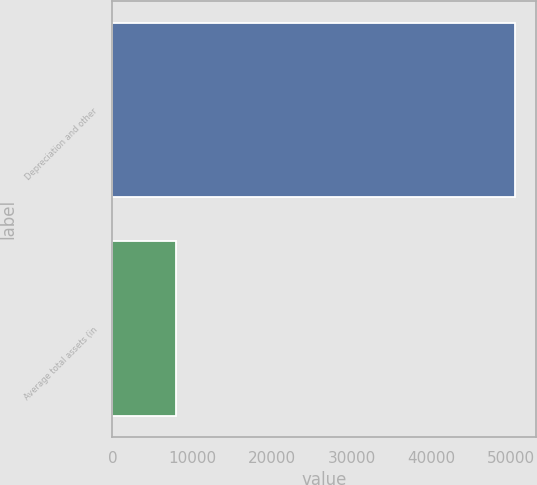Convert chart. <chart><loc_0><loc_0><loc_500><loc_500><bar_chart><fcel>Depreciation and other<fcel>Average total assets (in<nl><fcel>50536<fcel>7952<nl></chart> 